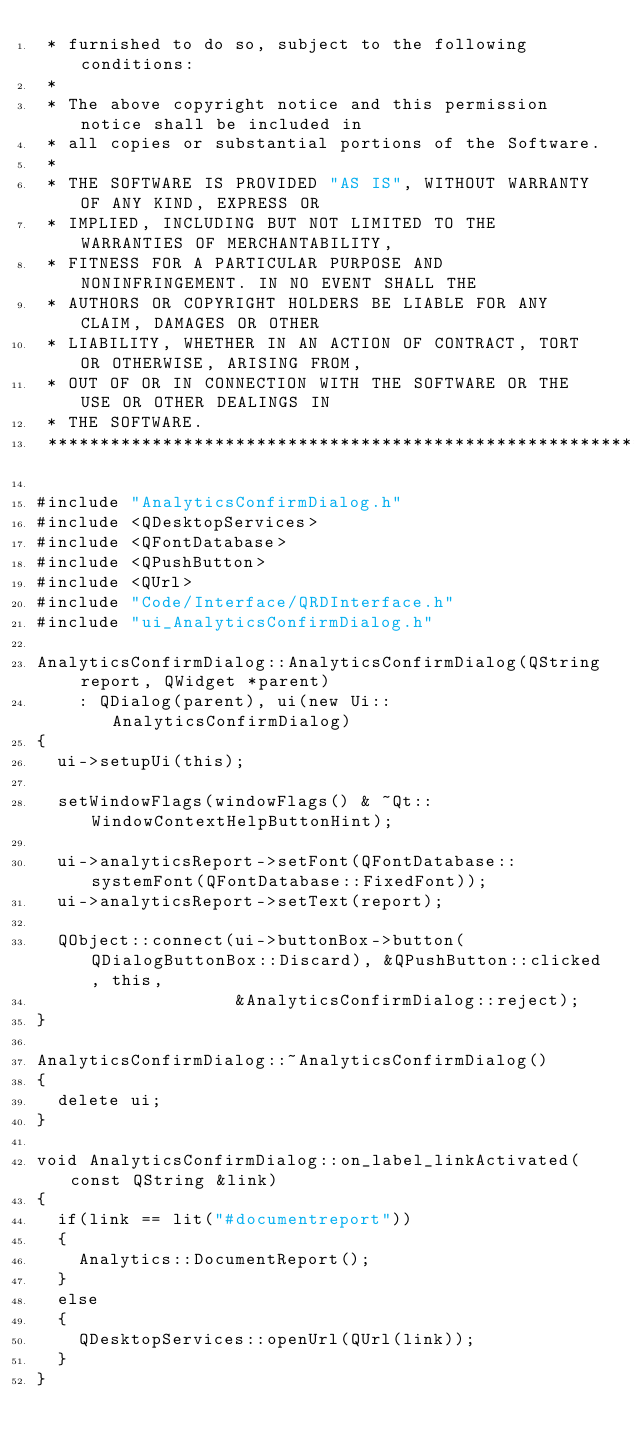<code> <loc_0><loc_0><loc_500><loc_500><_C++_> * furnished to do so, subject to the following conditions:
 *
 * The above copyright notice and this permission notice shall be included in
 * all copies or substantial portions of the Software.
 *
 * THE SOFTWARE IS PROVIDED "AS IS", WITHOUT WARRANTY OF ANY KIND, EXPRESS OR
 * IMPLIED, INCLUDING BUT NOT LIMITED TO THE WARRANTIES OF MERCHANTABILITY,
 * FITNESS FOR A PARTICULAR PURPOSE AND NONINFRINGEMENT. IN NO EVENT SHALL THE
 * AUTHORS OR COPYRIGHT HOLDERS BE LIABLE FOR ANY CLAIM, DAMAGES OR OTHER
 * LIABILITY, WHETHER IN AN ACTION OF CONTRACT, TORT OR OTHERWISE, ARISING FROM,
 * OUT OF OR IN CONNECTION WITH THE SOFTWARE OR THE USE OR OTHER DEALINGS IN
 * THE SOFTWARE.
 ******************************************************************************/

#include "AnalyticsConfirmDialog.h"
#include <QDesktopServices>
#include <QFontDatabase>
#include <QPushButton>
#include <QUrl>
#include "Code/Interface/QRDInterface.h"
#include "ui_AnalyticsConfirmDialog.h"

AnalyticsConfirmDialog::AnalyticsConfirmDialog(QString report, QWidget *parent)
    : QDialog(parent), ui(new Ui::AnalyticsConfirmDialog)
{
  ui->setupUi(this);

  setWindowFlags(windowFlags() & ~Qt::WindowContextHelpButtonHint);

  ui->analyticsReport->setFont(QFontDatabase::systemFont(QFontDatabase::FixedFont));
  ui->analyticsReport->setText(report);

  QObject::connect(ui->buttonBox->button(QDialogButtonBox::Discard), &QPushButton::clicked, this,
                   &AnalyticsConfirmDialog::reject);
}

AnalyticsConfirmDialog::~AnalyticsConfirmDialog()
{
  delete ui;
}

void AnalyticsConfirmDialog::on_label_linkActivated(const QString &link)
{
  if(link == lit("#documentreport"))
  {
    Analytics::DocumentReport();
  }
  else
  {
    QDesktopServices::openUrl(QUrl(link));
  }
}
</code> 